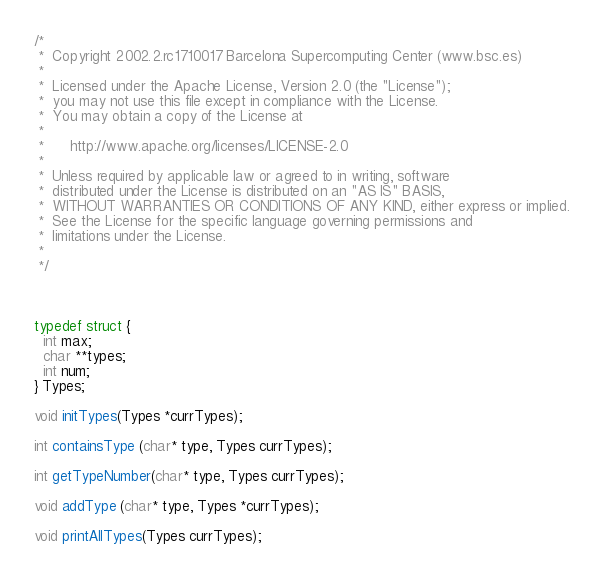Convert code to text. <code><loc_0><loc_0><loc_500><loc_500><_C_>/*         
 *  Copyright 2002.2.rc1710017 Barcelona Supercomputing Center (www.bsc.es)
 *
 *  Licensed under the Apache License, Version 2.0 (the "License");
 *  you may not use this file except in compliance with the License.
 *  You may obtain a copy of the License at
 *
 *      http://www.apache.org/licenses/LICENSE-2.0
 *
 *  Unless required by applicable law or agreed to in writing, software
 *  distributed under the License is distributed on an "AS IS" BASIS,
 *  WITHOUT WARRANTIES OR CONDITIONS OF ANY KIND, either express or implied.
 *  See the License for the specific language governing permissions and
 *  limitations under the License.
 *
 */



typedef struct {
  int max;
  char **types;
  int num;
} Types;

void initTypes(Types *currTypes);

int containsType (char* type, Types currTypes);

int getTypeNumber(char* type, Types currTypes);

void addType (char* type, Types *currTypes);

void printAllTypes(Types currTypes);
</code> 